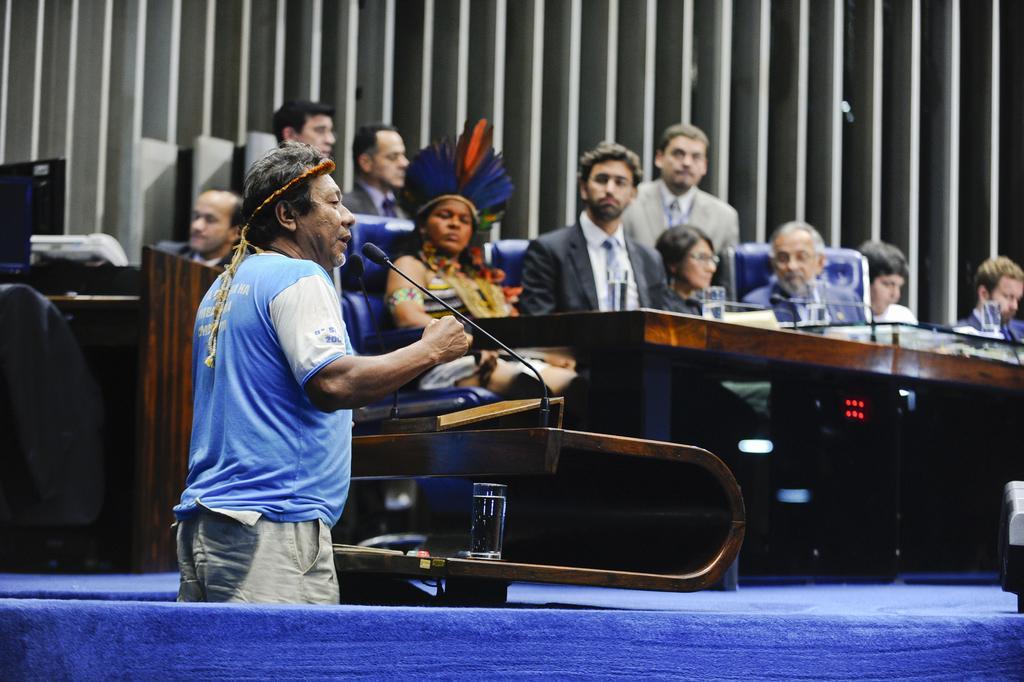Please provide a concise description of this image. In this image, we can see a group of people. Few are standing and sitting. Here we can see some wooden tables, few objects are placed on it. Here we can see a person is talking in-front of a microphone. At the bottom, we can see blue color. On the left side, we can see monitor, some objects. Background there is a wall. 